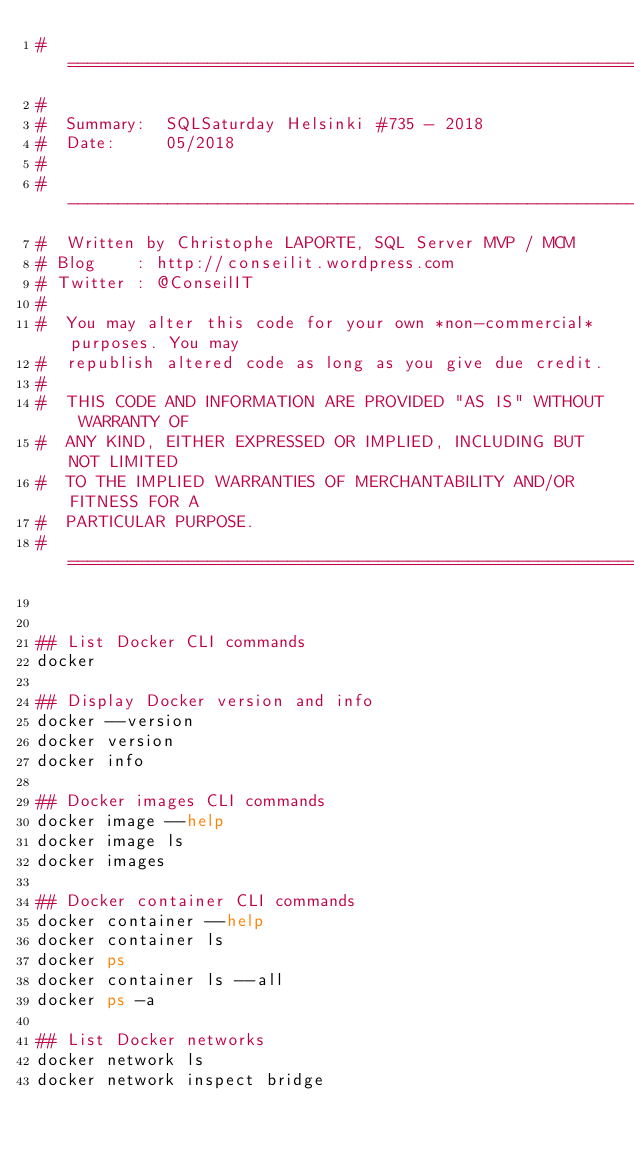<code> <loc_0><loc_0><loc_500><loc_500><_Bash_>#==============================================================================
#
#  Summary:  SQLSaturday Helsinki #735 - 2018
#  Date:     05/2018
#
#  ----------------------------------------------------------------------------
#  Written by Christophe LAPORTE, SQL Server MVP / MCM
#	Blog    : http://conseilit.wordpress.com
#	Twitter : @ConseilIT
#  
#  You may alter this code for your own *non-commercial* purposes. You may
#  republish altered code as long as you give due credit.
#  
#  THIS CODE AND INFORMATION ARE PROVIDED "AS IS" WITHOUT WARRANTY OF 
#  ANY KIND, EITHER EXPRESSED OR IMPLIED, INCLUDING BUT NOT LIMITED 
#  TO THE IMPLIED WARRANTIES OF MERCHANTABILITY AND/OR FITNESS FOR A
#  PARTICULAR PURPOSE.
#==============================================================================


## List Docker CLI commands
docker

## Display Docker version and info
docker --version
docker version
docker info

## Docker images CLI commands
docker image --help
docker image ls
docker images

## Docker container CLI commands
docker container --help
docker container ls
docker ps
docker container ls --all
docker ps -a

## List Docker networks
docker network ls 
docker network inspect bridge

</code> 